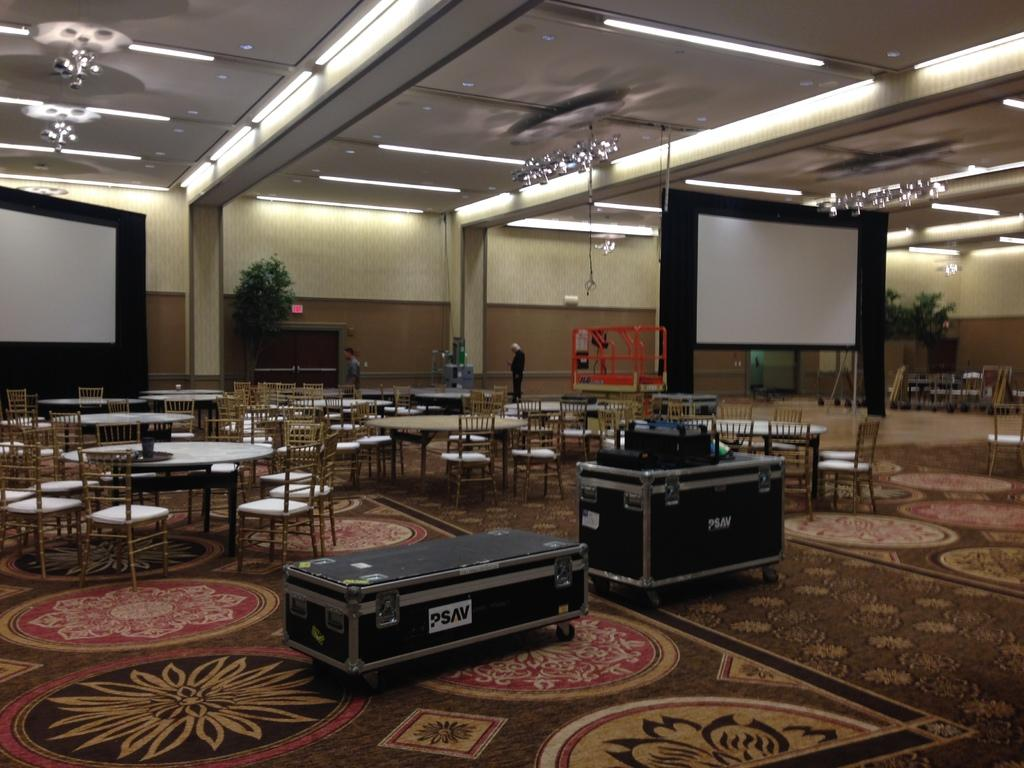What type of space is depicted in the image? The image shows an inside view of a hall. What furniture is present in the hall? There are tables and chairs in the hall. Are there any decorative elements in the hall? Yes, there is a plant in the hall. What kind of display device is in the hall? There is a screen in the hall. What structural element can be seen in the hall? There is a wall in the hall. What lighting is present in the hall? There are lights in the hall. How many trains are visible in the hall in the image? There are no trains visible in the hall in the image. What type of stem is present on the plant in the hall? The image does not provide enough detail to determine the type of stem on the plant in the hall. 